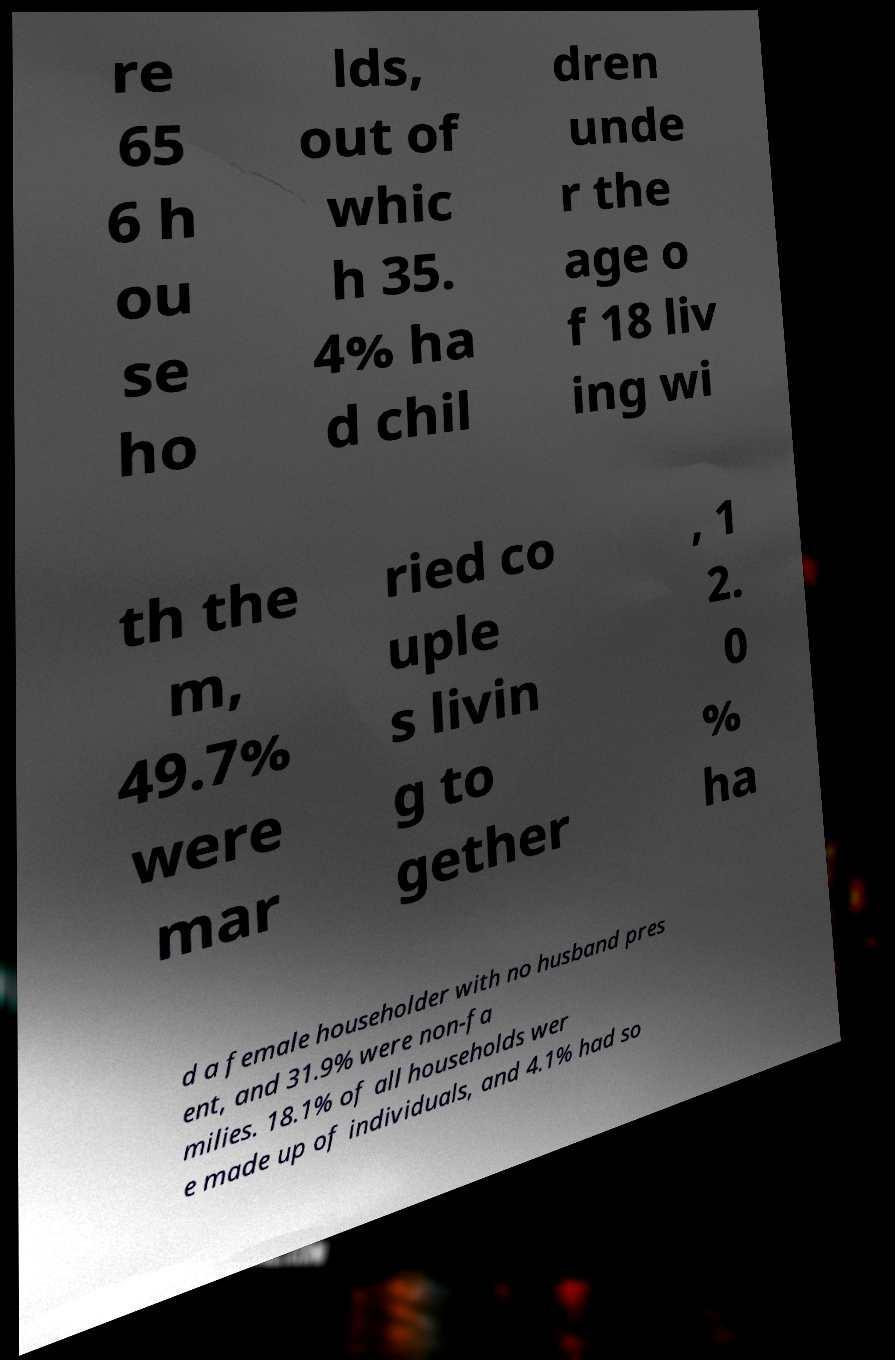What messages or text are displayed in this image? I need them in a readable, typed format. re 65 6 h ou se ho lds, out of whic h 35. 4% ha d chil dren unde r the age o f 18 liv ing wi th the m, 49.7% were mar ried co uple s livin g to gether , 1 2. 0 % ha d a female householder with no husband pres ent, and 31.9% were non-fa milies. 18.1% of all households wer e made up of individuals, and 4.1% had so 